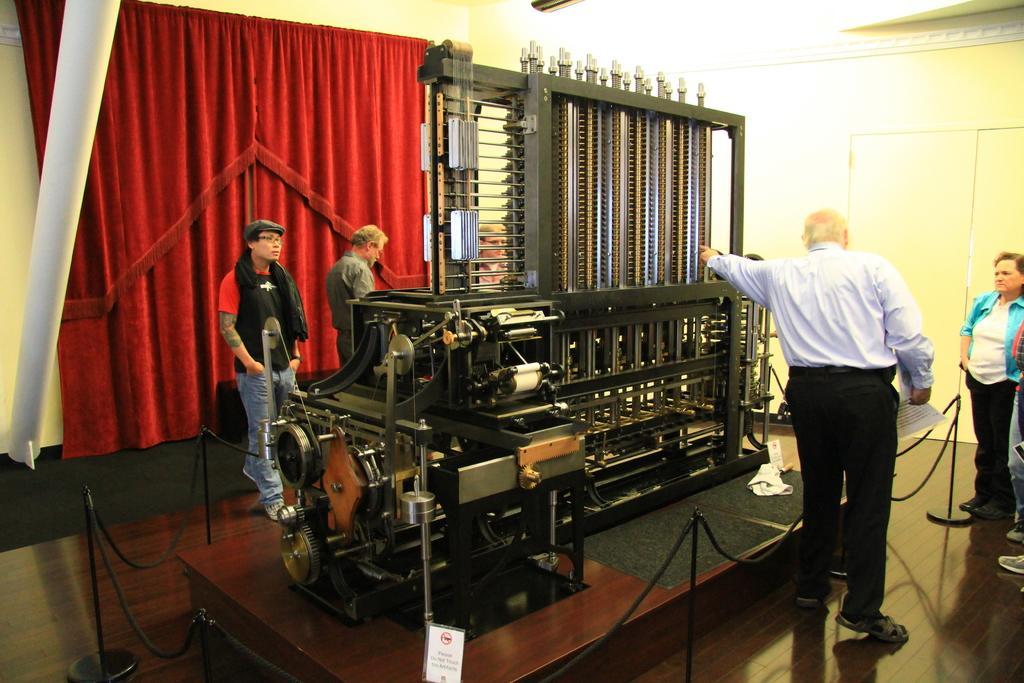Can you describe this image briefly? In this image there is a machine in the middle. On the right side there is a man who is pointing to the machine. On the left side there are red colour curtains to the wall. The machine is surrounded by the fence. On the left side there are two other persons on the floor. At the top there is light. 